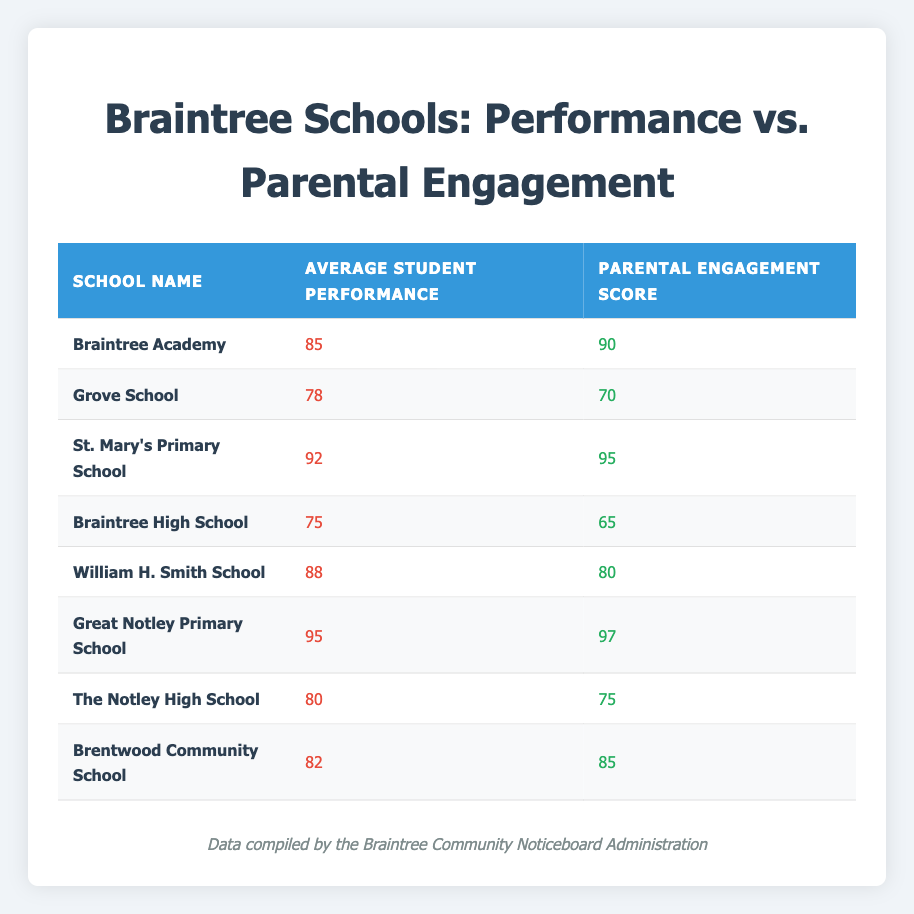What is the average student performance for Great Notley Primary School? The table lists Great Notley Primary School with an average student performance of 95.
Answer: 95 Which school has the highest parental engagement score? By reviewing the table, Great Notley Primary School has the highest parental engagement score at 97.
Answer: 97 Is the average student performance higher at St. Mary's Primary School than at Braintree High School? St. Mary's Primary School has an average student performance of 92, while Braintree High School has a performance of 75. Since 92 is greater than 75, it is indeed higher.
Answer: Yes What is the difference in parental engagement scores between Braintree Academy and Brentwood Community School? Braintree Academy has a parental engagement score of 90 and Brentwood Community School has a score of 85. The difference is 90 - 85 = 5.
Answer: 5 Calculate the average of average student performances across all schools in the table. Summing the average student performances: 85 + 78 + 92 + 75 + 88 + 95 + 80 + 82 = 695. There are 8 schools, so the average is 695 / 8 = 86.875.
Answer: 86.875 Is there a positive correlation between average student performance and parental engagement scores among the schools listed? Analyzing the data, schools with higher parental engagement scores tend to have higher average student performances (e.g., Great Notley Primary and St. Mary's). Thus, there is a positive correlation.
Answer: Yes Which schools have a parental engagement score above 80? The schools with a parental engagement score above 80 are Braintree Academy (90), St. Mary's Primary School (95), William H. Smith School (80), Great Notley Primary School (97), and Brentwood Community School (85).
Answer: 5 schools What is the average parental engagement score for the schools with average student performance below 80? The schools with average student performance below 80 are Grove School (70) and Braintree High School (65). The parental engagement scores for these schools are 70 and 65 respectively. The average is (70 + 65) / 2 = 67.5.
Answer: 67.5 